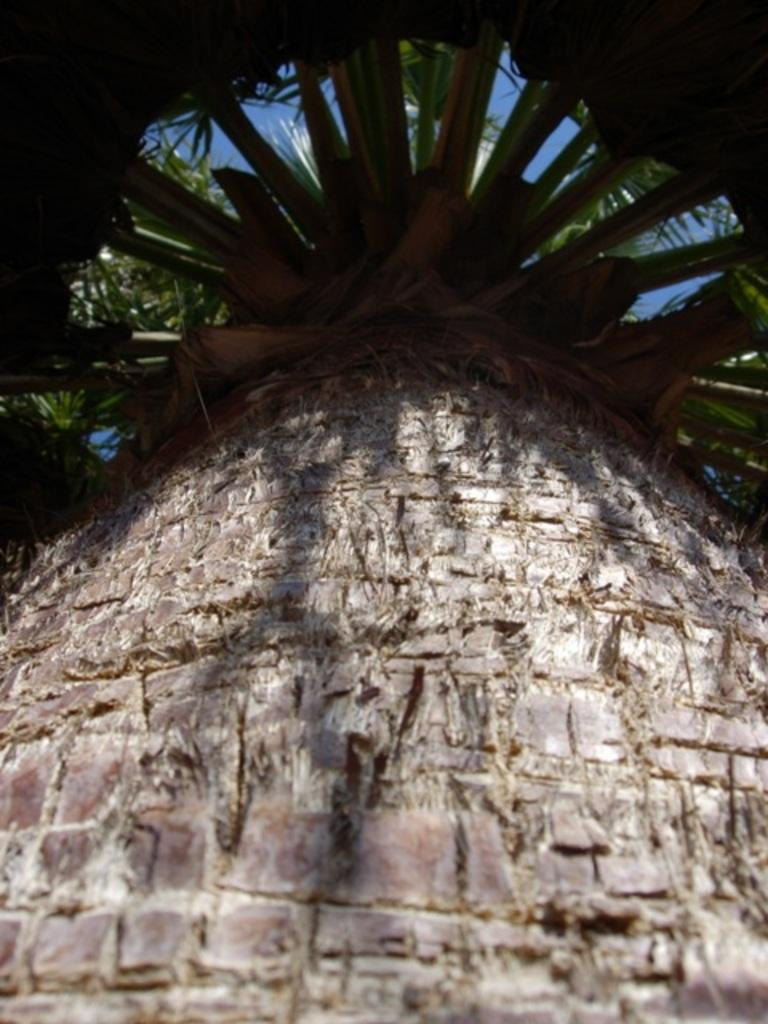What part of a tree is shown in the image? The image contains the bark of a tree and the branches of the tree. What can be seen in the background of the image? The sky is visible in the image. What type of quilt is hanging from the tree in the image? There is no quilt present in the image; it features the bark and branches of a tree with the sky visible in the background. 